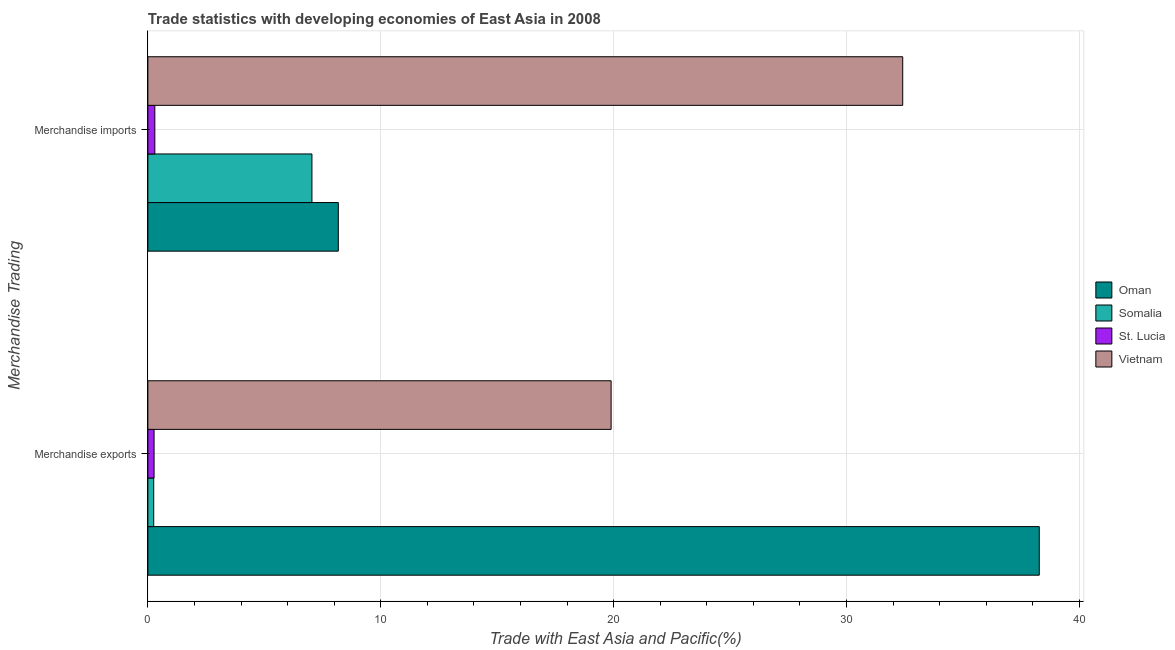Are the number of bars per tick equal to the number of legend labels?
Keep it short and to the point. Yes. What is the label of the 1st group of bars from the top?
Give a very brief answer. Merchandise imports. What is the merchandise imports in Vietnam?
Give a very brief answer. 32.41. Across all countries, what is the maximum merchandise exports?
Offer a terse response. 38.28. Across all countries, what is the minimum merchandise imports?
Make the answer very short. 0.3. In which country was the merchandise imports maximum?
Your response must be concise. Vietnam. In which country was the merchandise exports minimum?
Provide a succinct answer. Somalia. What is the total merchandise imports in the graph?
Make the answer very short. 47.93. What is the difference between the merchandise exports in St. Lucia and that in Oman?
Your answer should be very brief. -38.01. What is the difference between the merchandise exports in Oman and the merchandise imports in St. Lucia?
Your answer should be very brief. 37.98. What is the average merchandise exports per country?
Keep it short and to the point. 14.67. What is the difference between the merchandise exports and merchandise imports in Vietnam?
Provide a short and direct response. -12.52. What is the ratio of the merchandise imports in Somalia to that in Oman?
Your answer should be very brief. 0.86. Is the merchandise exports in St. Lucia less than that in Oman?
Give a very brief answer. Yes. In how many countries, is the merchandise imports greater than the average merchandise imports taken over all countries?
Your response must be concise. 1. What does the 2nd bar from the top in Merchandise exports represents?
Offer a terse response. St. Lucia. What does the 1st bar from the bottom in Merchandise imports represents?
Your answer should be compact. Oman. How many bars are there?
Provide a short and direct response. 8. Are all the bars in the graph horizontal?
Make the answer very short. Yes. How many countries are there in the graph?
Offer a very short reply. 4. Are the values on the major ticks of X-axis written in scientific E-notation?
Your answer should be compact. No. Does the graph contain any zero values?
Offer a terse response. No. Does the graph contain grids?
Give a very brief answer. Yes. How many legend labels are there?
Make the answer very short. 4. What is the title of the graph?
Ensure brevity in your answer.  Trade statistics with developing economies of East Asia in 2008. What is the label or title of the X-axis?
Give a very brief answer. Trade with East Asia and Pacific(%). What is the label or title of the Y-axis?
Offer a very short reply. Merchandise Trading. What is the Trade with East Asia and Pacific(%) in Oman in Merchandise exports?
Provide a short and direct response. 38.28. What is the Trade with East Asia and Pacific(%) of Somalia in Merchandise exports?
Ensure brevity in your answer.  0.25. What is the Trade with East Asia and Pacific(%) of St. Lucia in Merchandise exports?
Your response must be concise. 0.27. What is the Trade with East Asia and Pacific(%) in Vietnam in Merchandise exports?
Give a very brief answer. 19.89. What is the Trade with East Asia and Pacific(%) of Oman in Merchandise imports?
Your response must be concise. 8.18. What is the Trade with East Asia and Pacific(%) of Somalia in Merchandise imports?
Offer a very short reply. 7.04. What is the Trade with East Asia and Pacific(%) of St. Lucia in Merchandise imports?
Your response must be concise. 0.3. What is the Trade with East Asia and Pacific(%) in Vietnam in Merchandise imports?
Give a very brief answer. 32.41. Across all Merchandise Trading, what is the maximum Trade with East Asia and Pacific(%) in Oman?
Give a very brief answer. 38.28. Across all Merchandise Trading, what is the maximum Trade with East Asia and Pacific(%) in Somalia?
Give a very brief answer. 7.04. Across all Merchandise Trading, what is the maximum Trade with East Asia and Pacific(%) in St. Lucia?
Make the answer very short. 0.3. Across all Merchandise Trading, what is the maximum Trade with East Asia and Pacific(%) of Vietnam?
Your answer should be very brief. 32.41. Across all Merchandise Trading, what is the minimum Trade with East Asia and Pacific(%) of Oman?
Your response must be concise. 8.18. Across all Merchandise Trading, what is the minimum Trade with East Asia and Pacific(%) of Somalia?
Make the answer very short. 0.25. Across all Merchandise Trading, what is the minimum Trade with East Asia and Pacific(%) in St. Lucia?
Ensure brevity in your answer.  0.27. Across all Merchandise Trading, what is the minimum Trade with East Asia and Pacific(%) in Vietnam?
Provide a short and direct response. 19.89. What is the total Trade with East Asia and Pacific(%) of Oman in the graph?
Make the answer very short. 46.45. What is the total Trade with East Asia and Pacific(%) of Somalia in the graph?
Offer a terse response. 7.3. What is the total Trade with East Asia and Pacific(%) of St. Lucia in the graph?
Make the answer very short. 0.57. What is the total Trade with East Asia and Pacific(%) of Vietnam in the graph?
Ensure brevity in your answer.  52.31. What is the difference between the Trade with East Asia and Pacific(%) in Oman in Merchandise exports and that in Merchandise imports?
Give a very brief answer. 30.1. What is the difference between the Trade with East Asia and Pacific(%) in Somalia in Merchandise exports and that in Merchandise imports?
Ensure brevity in your answer.  -6.79. What is the difference between the Trade with East Asia and Pacific(%) in St. Lucia in Merchandise exports and that in Merchandise imports?
Give a very brief answer. -0.03. What is the difference between the Trade with East Asia and Pacific(%) of Vietnam in Merchandise exports and that in Merchandise imports?
Provide a succinct answer. -12.52. What is the difference between the Trade with East Asia and Pacific(%) in Oman in Merchandise exports and the Trade with East Asia and Pacific(%) in Somalia in Merchandise imports?
Make the answer very short. 31.23. What is the difference between the Trade with East Asia and Pacific(%) of Oman in Merchandise exports and the Trade with East Asia and Pacific(%) of St. Lucia in Merchandise imports?
Your answer should be compact. 37.98. What is the difference between the Trade with East Asia and Pacific(%) in Oman in Merchandise exports and the Trade with East Asia and Pacific(%) in Vietnam in Merchandise imports?
Keep it short and to the point. 5.86. What is the difference between the Trade with East Asia and Pacific(%) of Somalia in Merchandise exports and the Trade with East Asia and Pacific(%) of St. Lucia in Merchandise imports?
Ensure brevity in your answer.  -0.05. What is the difference between the Trade with East Asia and Pacific(%) of Somalia in Merchandise exports and the Trade with East Asia and Pacific(%) of Vietnam in Merchandise imports?
Offer a very short reply. -32.16. What is the difference between the Trade with East Asia and Pacific(%) in St. Lucia in Merchandise exports and the Trade with East Asia and Pacific(%) in Vietnam in Merchandise imports?
Provide a short and direct response. -32.15. What is the average Trade with East Asia and Pacific(%) of Oman per Merchandise Trading?
Provide a succinct answer. 23.23. What is the average Trade with East Asia and Pacific(%) of Somalia per Merchandise Trading?
Your response must be concise. 3.65. What is the average Trade with East Asia and Pacific(%) in St. Lucia per Merchandise Trading?
Provide a short and direct response. 0.28. What is the average Trade with East Asia and Pacific(%) of Vietnam per Merchandise Trading?
Your answer should be very brief. 26.15. What is the difference between the Trade with East Asia and Pacific(%) of Oman and Trade with East Asia and Pacific(%) of Somalia in Merchandise exports?
Give a very brief answer. 38.03. What is the difference between the Trade with East Asia and Pacific(%) of Oman and Trade with East Asia and Pacific(%) of St. Lucia in Merchandise exports?
Your answer should be compact. 38.01. What is the difference between the Trade with East Asia and Pacific(%) of Oman and Trade with East Asia and Pacific(%) of Vietnam in Merchandise exports?
Give a very brief answer. 18.38. What is the difference between the Trade with East Asia and Pacific(%) of Somalia and Trade with East Asia and Pacific(%) of St. Lucia in Merchandise exports?
Offer a very short reply. -0.02. What is the difference between the Trade with East Asia and Pacific(%) in Somalia and Trade with East Asia and Pacific(%) in Vietnam in Merchandise exports?
Provide a succinct answer. -19.64. What is the difference between the Trade with East Asia and Pacific(%) of St. Lucia and Trade with East Asia and Pacific(%) of Vietnam in Merchandise exports?
Your response must be concise. -19.63. What is the difference between the Trade with East Asia and Pacific(%) in Oman and Trade with East Asia and Pacific(%) in Somalia in Merchandise imports?
Give a very brief answer. 1.13. What is the difference between the Trade with East Asia and Pacific(%) in Oman and Trade with East Asia and Pacific(%) in St. Lucia in Merchandise imports?
Provide a short and direct response. 7.88. What is the difference between the Trade with East Asia and Pacific(%) of Oman and Trade with East Asia and Pacific(%) of Vietnam in Merchandise imports?
Make the answer very short. -24.24. What is the difference between the Trade with East Asia and Pacific(%) of Somalia and Trade with East Asia and Pacific(%) of St. Lucia in Merchandise imports?
Provide a succinct answer. 6.75. What is the difference between the Trade with East Asia and Pacific(%) in Somalia and Trade with East Asia and Pacific(%) in Vietnam in Merchandise imports?
Offer a terse response. -25.37. What is the difference between the Trade with East Asia and Pacific(%) of St. Lucia and Trade with East Asia and Pacific(%) of Vietnam in Merchandise imports?
Provide a short and direct response. -32.11. What is the ratio of the Trade with East Asia and Pacific(%) in Oman in Merchandise exports to that in Merchandise imports?
Your answer should be very brief. 4.68. What is the ratio of the Trade with East Asia and Pacific(%) of Somalia in Merchandise exports to that in Merchandise imports?
Your answer should be very brief. 0.04. What is the ratio of the Trade with East Asia and Pacific(%) of St. Lucia in Merchandise exports to that in Merchandise imports?
Provide a short and direct response. 0.89. What is the ratio of the Trade with East Asia and Pacific(%) of Vietnam in Merchandise exports to that in Merchandise imports?
Your answer should be compact. 0.61. What is the difference between the highest and the second highest Trade with East Asia and Pacific(%) in Oman?
Give a very brief answer. 30.1. What is the difference between the highest and the second highest Trade with East Asia and Pacific(%) in Somalia?
Your answer should be compact. 6.79. What is the difference between the highest and the second highest Trade with East Asia and Pacific(%) of St. Lucia?
Your answer should be compact. 0.03. What is the difference between the highest and the second highest Trade with East Asia and Pacific(%) in Vietnam?
Your response must be concise. 12.52. What is the difference between the highest and the lowest Trade with East Asia and Pacific(%) of Oman?
Your response must be concise. 30.1. What is the difference between the highest and the lowest Trade with East Asia and Pacific(%) of Somalia?
Make the answer very short. 6.79. What is the difference between the highest and the lowest Trade with East Asia and Pacific(%) in St. Lucia?
Your answer should be very brief. 0.03. What is the difference between the highest and the lowest Trade with East Asia and Pacific(%) in Vietnam?
Keep it short and to the point. 12.52. 